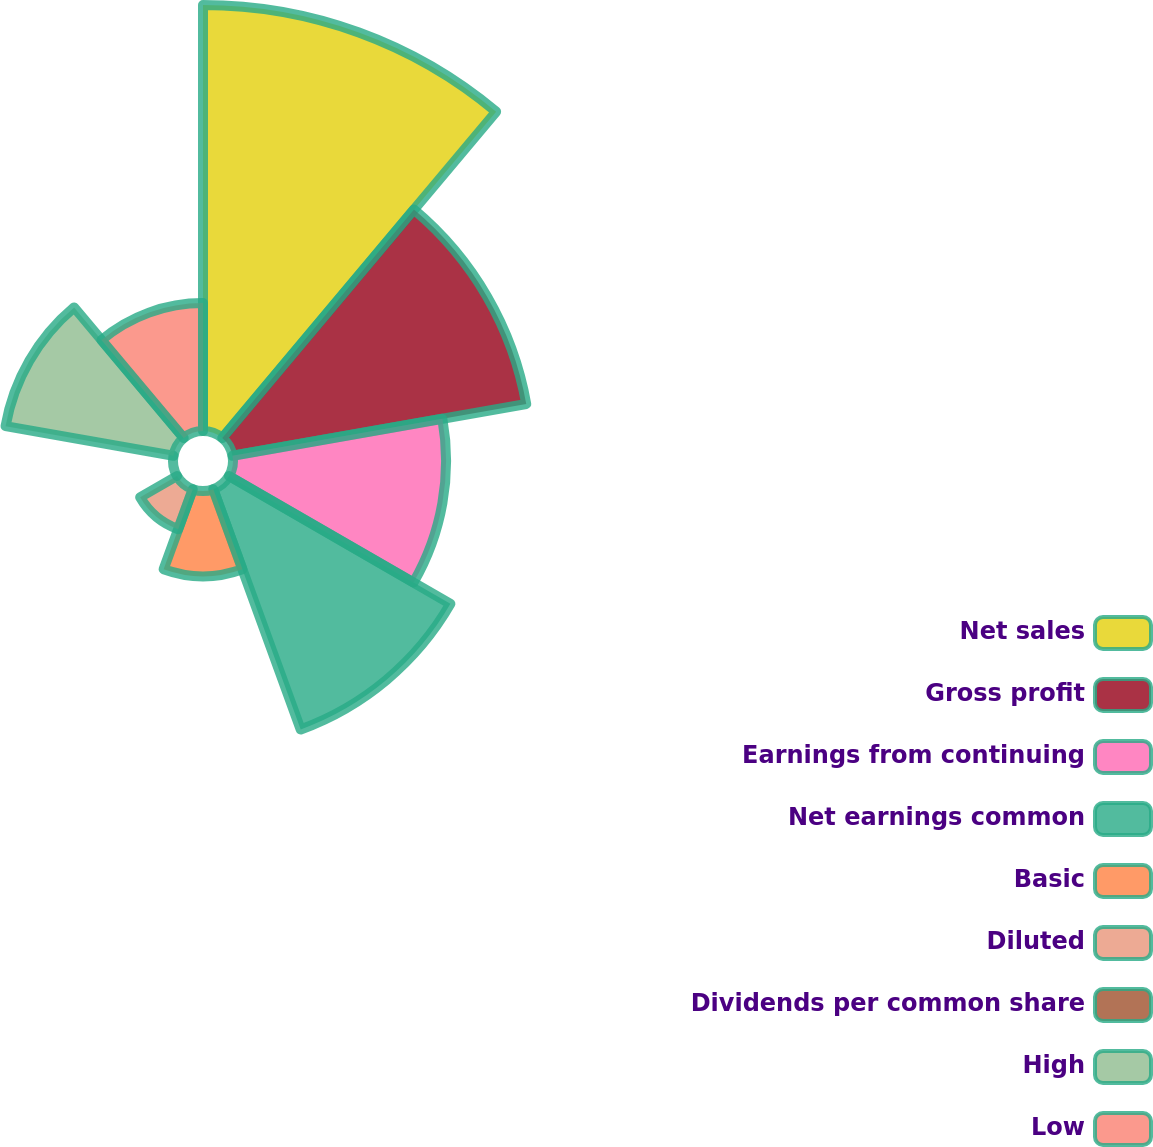Convert chart. <chart><loc_0><loc_0><loc_500><loc_500><pie_chart><fcel>Net sales<fcel>Gross profit<fcel>Earnings from continuing<fcel>Net earnings common<fcel>Basic<fcel>Diluted<fcel>Dividends per common share<fcel>High<fcel>Low<nl><fcel>26.31%<fcel>18.42%<fcel>13.16%<fcel>15.79%<fcel>5.26%<fcel>2.63%<fcel>0.0%<fcel>10.53%<fcel>7.9%<nl></chart> 